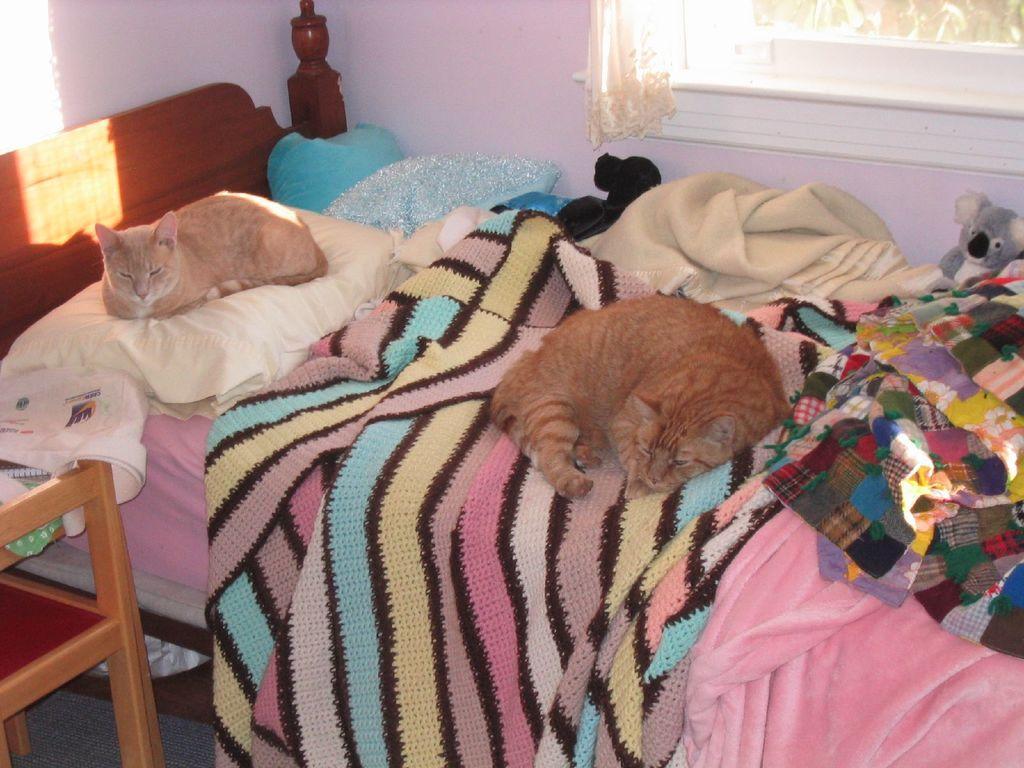Could you give a brief overview of what you see in this image? Here we can see a two cats which are on the bed. This looks like a window and this is a teddy bear. 